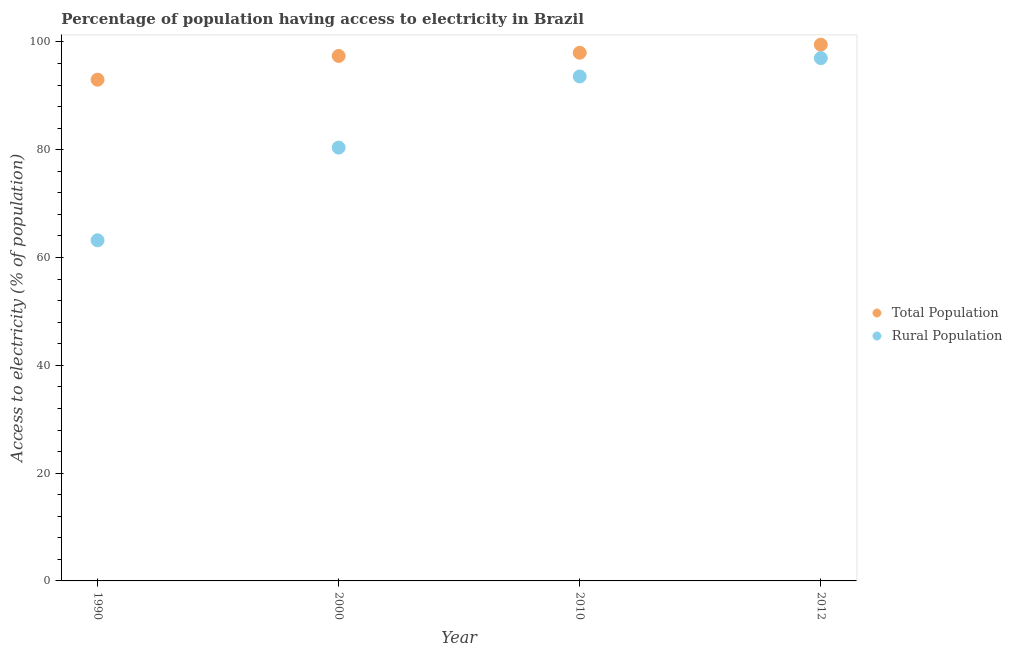How many different coloured dotlines are there?
Ensure brevity in your answer.  2. What is the percentage of rural population having access to electricity in 2000?
Ensure brevity in your answer.  80.4. Across all years, what is the maximum percentage of rural population having access to electricity?
Keep it short and to the point. 97. Across all years, what is the minimum percentage of population having access to electricity?
Offer a very short reply. 93. In which year was the percentage of rural population having access to electricity maximum?
Provide a succinct answer. 2012. In which year was the percentage of rural population having access to electricity minimum?
Your response must be concise. 1990. What is the total percentage of population having access to electricity in the graph?
Your answer should be very brief. 387.9. What is the difference between the percentage of population having access to electricity in 2010 and that in 2012?
Provide a short and direct response. -1.5. What is the difference between the percentage of rural population having access to electricity in 1990 and the percentage of population having access to electricity in 2000?
Offer a terse response. -34.2. What is the average percentage of rural population having access to electricity per year?
Provide a short and direct response. 83.55. In the year 1990, what is the difference between the percentage of rural population having access to electricity and percentage of population having access to electricity?
Your answer should be very brief. -29.8. What is the ratio of the percentage of population having access to electricity in 2000 to that in 2010?
Provide a succinct answer. 0.99. Is the percentage of rural population having access to electricity in 1990 less than that in 2000?
Provide a succinct answer. Yes. Is the difference between the percentage of rural population having access to electricity in 2000 and 2010 greater than the difference between the percentage of population having access to electricity in 2000 and 2010?
Provide a succinct answer. No. What is the difference between the highest and the second highest percentage of rural population having access to electricity?
Your answer should be compact. 3.4. Does the percentage of population having access to electricity monotonically increase over the years?
Provide a succinct answer. Yes. How many years are there in the graph?
Your answer should be compact. 4. Does the graph contain any zero values?
Offer a terse response. No. How many legend labels are there?
Your answer should be very brief. 2. How are the legend labels stacked?
Ensure brevity in your answer.  Vertical. What is the title of the graph?
Your answer should be compact. Percentage of population having access to electricity in Brazil. Does "Adolescent fertility rate" appear as one of the legend labels in the graph?
Make the answer very short. No. What is the label or title of the Y-axis?
Provide a short and direct response. Access to electricity (% of population). What is the Access to electricity (% of population) of Total Population in 1990?
Your answer should be very brief. 93. What is the Access to electricity (% of population) of Rural Population in 1990?
Keep it short and to the point. 63.2. What is the Access to electricity (% of population) in Total Population in 2000?
Make the answer very short. 97.4. What is the Access to electricity (% of population) in Rural Population in 2000?
Offer a terse response. 80.4. What is the Access to electricity (% of population) in Total Population in 2010?
Ensure brevity in your answer.  98. What is the Access to electricity (% of population) of Rural Population in 2010?
Provide a succinct answer. 93.6. What is the Access to electricity (% of population) in Total Population in 2012?
Ensure brevity in your answer.  99.5. What is the Access to electricity (% of population) in Rural Population in 2012?
Your response must be concise. 97. Across all years, what is the maximum Access to electricity (% of population) in Total Population?
Your response must be concise. 99.5. Across all years, what is the maximum Access to electricity (% of population) of Rural Population?
Offer a very short reply. 97. Across all years, what is the minimum Access to electricity (% of population) of Total Population?
Your answer should be very brief. 93. Across all years, what is the minimum Access to electricity (% of population) in Rural Population?
Provide a short and direct response. 63.2. What is the total Access to electricity (% of population) of Total Population in the graph?
Offer a very short reply. 387.9. What is the total Access to electricity (% of population) in Rural Population in the graph?
Provide a succinct answer. 334.2. What is the difference between the Access to electricity (% of population) of Rural Population in 1990 and that in 2000?
Your answer should be compact. -17.2. What is the difference between the Access to electricity (% of population) of Rural Population in 1990 and that in 2010?
Your response must be concise. -30.4. What is the difference between the Access to electricity (% of population) in Rural Population in 1990 and that in 2012?
Provide a short and direct response. -33.8. What is the difference between the Access to electricity (% of population) in Rural Population in 2000 and that in 2010?
Your answer should be very brief. -13.2. What is the difference between the Access to electricity (% of population) of Rural Population in 2000 and that in 2012?
Ensure brevity in your answer.  -16.6. What is the difference between the Access to electricity (% of population) of Total Population in 2010 and that in 2012?
Make the answer very short. -1.5. What is the difference between the Access to electricity (% of population) in Total Population in 2000 and the Access to electricity (% of population) in Rural Population in 2010?
Provide a short and direct response. 3.8. What is the difference between the Access to electricity (% of population) in Total Population in 2000 and the Access to electricity (% of population) in Rural Population in 2012?
Provide a succinct answer. 0.4. What is the difference between the Access to electricity (% of population) in Total Population in 2010 and the Access to electricity (% of population) in Rural Population in 2012?
Provide a short and direct response. 1. What is the average Access to electricity (% of population) in Total Population per year?
Your answer should be compact. 96.97. What is the average Access to electricity (% of population) in Rural Population per year?
Provide a succinct answer. 83.55. In the year 1990, what is the difference between the Access to electricity (% of population) of Total Population and Access to electricity (% of population) of Rural Population?
Your answer should be very brief. 29.8. What is the ratio of the Access to electricity (% of population) of Total Population in 1990 to that in 2000?
Offer a terse response. 0.95. What is the ratio of the Access to electricity (% of population) of Rural Population in 1990 to that in 2000?
Make the answer very short. 0.79. What is the ratio of the Access to electricity (% of population) of Total Population in 1990 to that in 2010?
Provide a short and direct response. 0.95. What is the ratio of the Access to electricity (% of population) of Rural Population in 1990 to that in 2010?
Give a very brief answer. 0.68. What is the ratio of the Access to electricity (% of population) in Total Population in 1990 to that in 2012?
Your response must be concise. 0.93. What is the ratio of the Access to electricity (% of population) of Rural Population in 1990 to that in 2012?
Provide a short and direct response. 0.65. What is the ratio of the Access to electricity (% of population) in Rural Population in 2000 to that in 2010?
Give a very brief answer. 0.86. What is the ratio of the Access to electricity (% of population) of Total Population in 2000 to that in 2012?
Give a very brief answer. 0.98. What is the ratio of the Access to electricity (% of population) of Rural Population in 2000 to that in 2012?
Offer a very short reply. 0.83. What is the ratio of the Access to electricity (% of population) in Total Population in 2010 to that in 2012?
Make the answer very short. 0.98. What is the ratio of the Access to electricity (% of population) of Rural Population in 2010 to that in 2012?
Ensure brevity in your answer.  0.96. What is the difference between the highest and the second highest Access to electricity (% of population) in Total Population?
Offer a terse response. 1.5. What is the difference between the highest and the lowest Access to electricity (% of population) of Total Population?
Offer a very short reply. 6.5. What is the difference between the highest and the lowest Access to electricity (% of population) in Rural Population?
Provide a short and direct response. 33.8. 